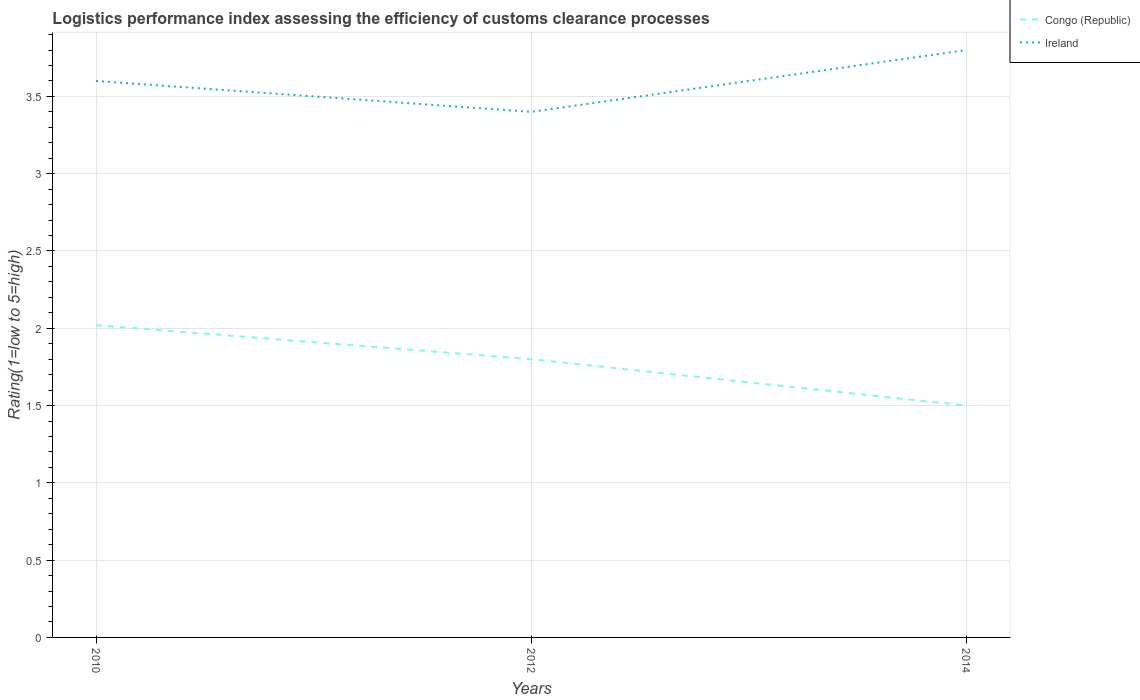What is the total Logistic performance index in Congo (Republic) in the graph?
Give a very brief answer. 0.3. What is the difference between the highest and the second highest Logistic performance index in Ireland?
Provide a short and direct response. 0.4. What is the difference between the highest and the lowest Logistic performance index in Congo (Republic)?
Offer a very short reply. 2. How many lines are there?
Your answer should be very brief. 2. Where does the legend appear in the graph?
Give a very brief answer. Top right. How are the legend labels stacked?
Provide a succinct answer. Vertical. What is the title of the graph?
Offer a very short reply. Logistics performance index assessing the efficiency of customs clearance processes. What is the label or title of the Y-axis?
Give a very brief answer. Rating(1=low to 5=high). What is the Rating(1=low to 5=high) in Congo (Republic) in 2010?
Provide a short and direct response. 2.02. What is the Rating(1=low to 5=high) in Ireland in 2014?
Make the answer very short. 3.8. Across all years, what is the maximum Rating(1=low to 5=high) in Congo (Republic)?
Offer a terse response. 2.02. Across all years, what is the maximum Rating(1=low to 5=high) in Ireland?
Give a very brief answer. 3.8. Across all years, what is the minimum Rating(1=low to 5=high) in Congo (Republic)?
Your answer should be very brief. 1.5. Across all years, what is the minimum Rating(1=low to 5=high) in Ireland?
Your answer should be compact. 3.4. What is the total Rating(1=low to 5=high) of Congo (Republic) in the graph?
Provide a succinct answer. 5.32. What is the difference between the Rating(1=low to 5=high) of Congo (Republic) in 2010 and that in 2012?
Offer a very short reply. 0.22. What is the difference between the Rating(1=low to 5=high) in Ireland in 2010 and that in 2012?
Give a very brief answer. 0.2. What is the difference between the Rating(1=low to 5=high) of Congo (Republic) in 2010 and that in 2014?
Provide a succinct answer. 0.52. What is the difference between the Rating(1=low to 5=high) in Congo (Republic) in 2012 and that in 2014?
Keep it short and to the point. 0.3. What is the difference between the Rating(1=low to 5=high) of Congo (Republic) in 2010 and the Rating(1=low to 5=high) of Ireland in 2012?
Keep it short and to the point. -1.38. What is the difference between the Rating(1=low to 5=high) in Congo (Republic) in 2010 and the Rating(1=low to 5=high) in Ireland in 2014?
Your response must be concise. -1.78. What is the average Rating(1=low to 5=high) in Congo (Republic) per year?
Give a very brief answer. 1.77. What is the average Rating(1=low to 5=high) in Ireland per year?
Your answer should be compact. 3.6. In the year 2010, what is the difference between the Rating(1=low to 5=high) of Congo (Republic) and Rating(1=low to 5=high) of Ireland?
Offer a terse response. -1.58. In the year 2014, what is the difference between the Rating(1=low to 5=high) of Congo (Republic) and Rating(1=low to 5=high) of Ireland?
Your response must be concise. -2.3. What is the ratio of the Rating(1=low to 5=high) in Congo (Republic) in 2010 to that in 2012?
Ensure brevity in your answer.  1.12. What is the ratio of the Rating(1=low to 5=high) in Ireland in 2010 to that in 2012?
Your answer should be very brief. 1.06. What is the ratio of the Rating(1=low to 5=high) of Congo (Republic) in 2010 to that in 2014?
Your answer should be very brief. 1.35. What is the ratio of the Rating(1=low to 5=high) of Congo (Republic) in 2012 to that in 2014?
Provide a succinct answer. 1.2. What is the ratio of the Rating(1=low to 5=high) of Ireland in 2012 to that in 2014?
Your response must be concise. 0.89. What is the difference between the highest and the second highest Rating(1=low to 5=high) in Congo (Republic)?
Your response must be concise. 0.22. What is the difference between the highest and the lowest Rating(1=low to 5=high) in Congo (Republic)?
Provide a succinct answer. 0.52. 